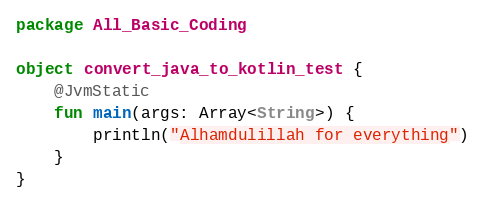Convert code to text. <code><loc_0><loc_0><loc_500><loc_500><_Kotlin_>package All_Basic_Coding

object convert_java_to_kotlin_test {
    @JvmStatic
    fun main(args: Array<String>) {
        println("Alhamdulillah for everything")
    }
}
</code> 